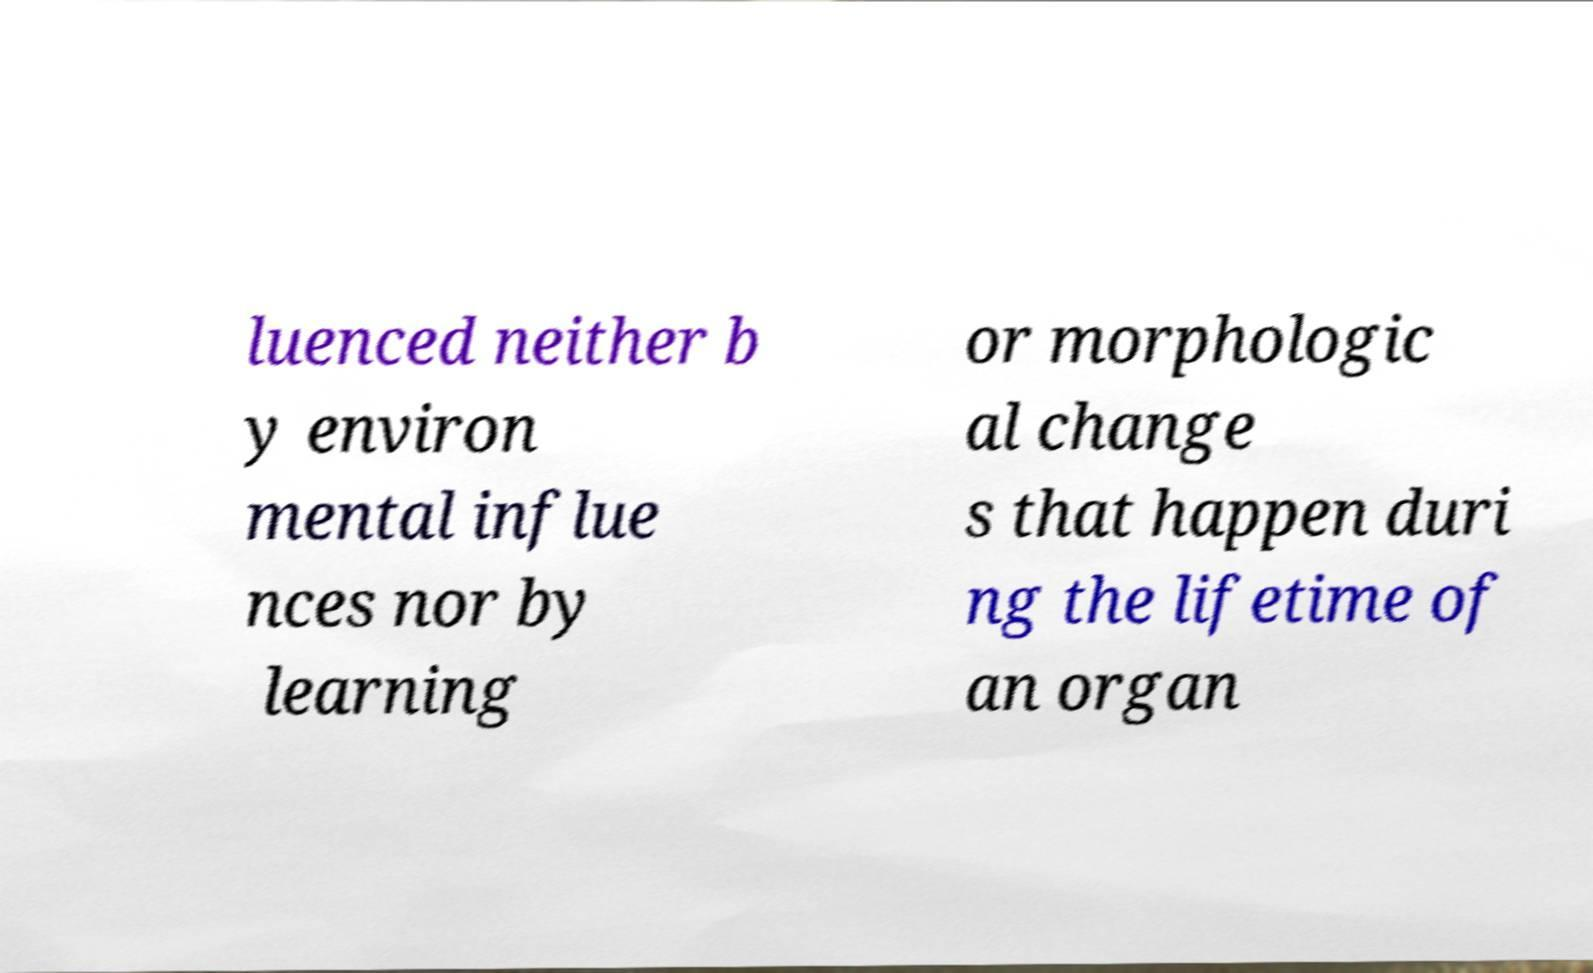I need the written content from this picture converted into text. Can you do that? luenced neither b y environ mental influe nces nor by learning or morphologic al change s that happen duri ng the lifetime of an organ 